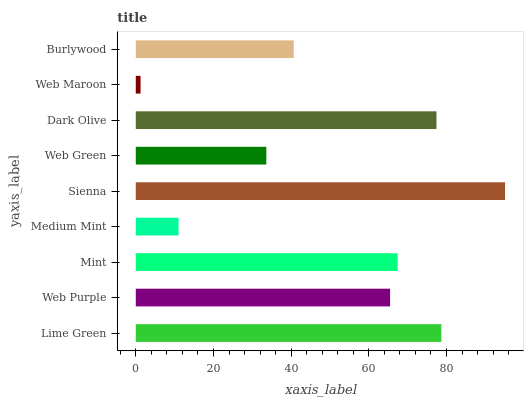Is Web Maroon the minimum?
Answer yes or no. Yes. Is Sienna the maximum?
Answer yes or no. Yes. Is Web Purple the minimum?
Answer yes or no. No. Is Web Purple the maximum?
Answer yes or no. No. Is Lime Green greater than Web Purple?
Answer yes or no. Yes. Is Web Purple less than Lime Green?
Answer yes or no. Yes. Is Web Purple greater than Lime Green?
Answer yes or no. No. Is Lime Green less than Web Purple?
Answer yes or no. No. Is Web Purple the high median?
Answer yes or no. Yes. Is Web Purple the low median?
Answer yes or no. Yes. Is Mint the high median?
Answer yes or no. No. Is Dark Olive the low median?
Answer yes or no. No. 